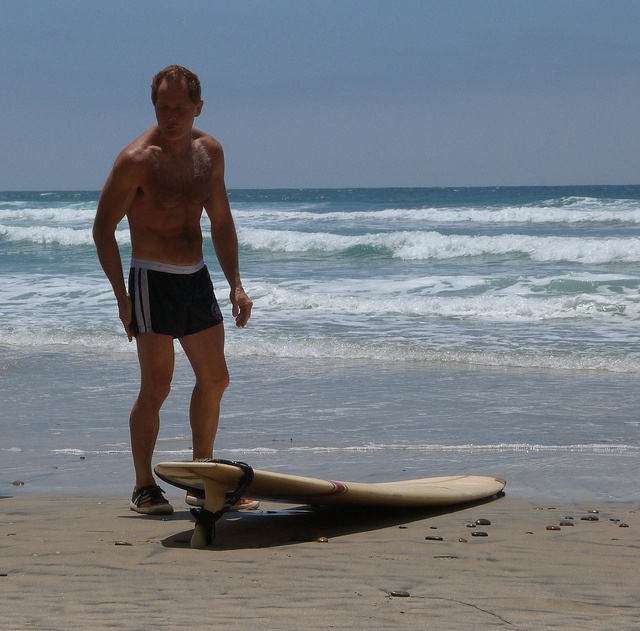Describe the objects in this image and their specific colors. I can see people in gray, black, maroon, and darkgray tones and surfboard in gray, black, and darkgray tones in this image. 